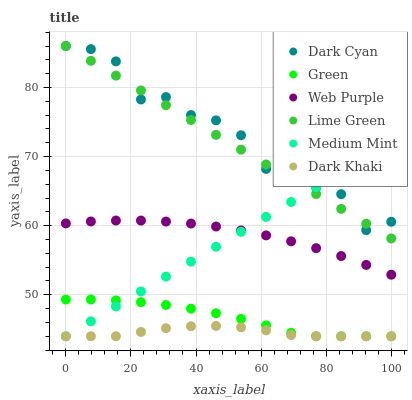Does Dark Khaki have the minimum area under the curve?
Answer yes or no. Yes. Does Dark Cyan have the maximum area under the curve?
Answer yes or no. Yes. Does Web Purple have the minimum area under the curve?
Answer yes or no. No. Does Web Purple have the maximum area under the curve?
Answer yes or no. No. Is Medium Mint the smoothest?
Answer yes or no. Yes. Is Dark Cyan the roughest?
Answer yes or no. Yes. Is Dark Khaki the smoothest?
Answer yes or no. No. Is Dark Khaki the roughest?
Answer yes or no. No. Does Medium Mint have the lowest value?
Answer yes or no. Yes. Does Web Purple have the lowest value?
Answer yes or no. No. Does Lime Green have the highest value?
Answer yes or no. Yes. Does Web Purple have the highest value?
Answer yes or no. No. Is Dark Khaki less than Lime Green?
Answer yes or no. Yes. Is Dark Cyan greater than Green?
Answer yes or no. Yes. Does Green intersect Dark Khaki?
Answer yes or no. Yes. Is Green less than Dark Khaki?
Answer yes or no. No. Is Green greater than Dark Khaki?
Answer yes or no. No. Does Dark Khaki intersect Lime Green?
Answer yes or no. No. 